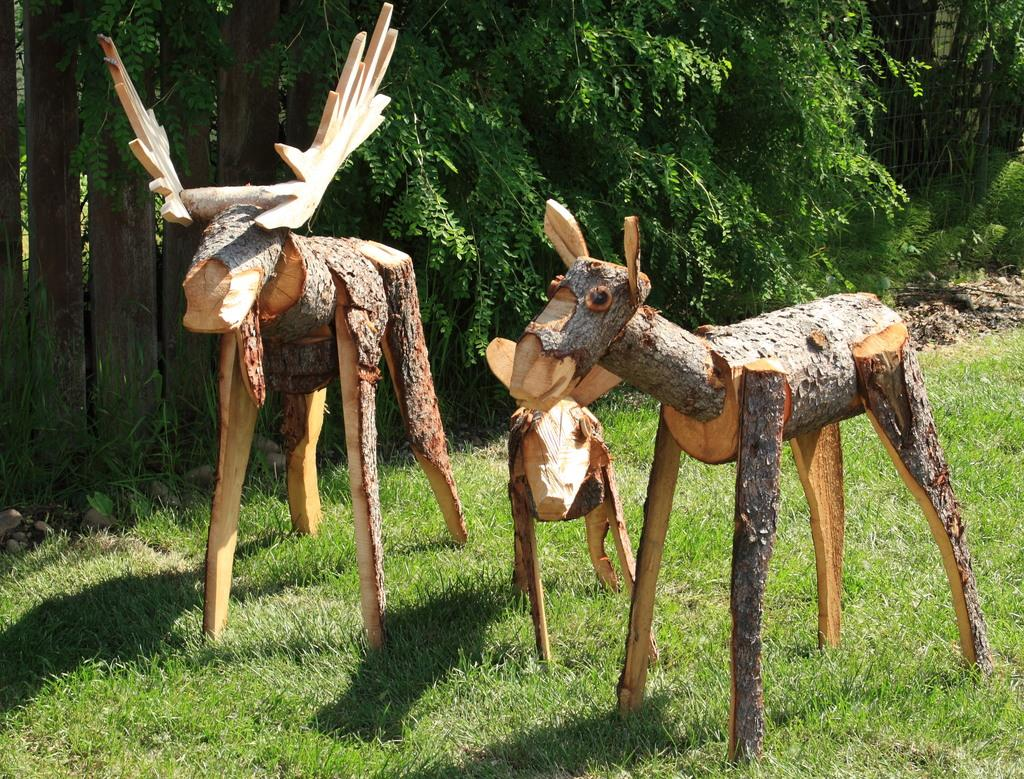What type of vegetation is present in the image? There are many trees in the image. What is the color of the grass at the bottom of the image? The grass at the bottom of the image is green. What are the wooden objects in the front of the image? There are artificial animals made up of wood in the front of the image. Can you tell me how many balls are hidden in the trees in the image? There are no balls present in the image; it features trees, green grass, and wooden animals. How does the cake get pushed around in the image? There is no cake present in the image, so it cannot be pushed around. 